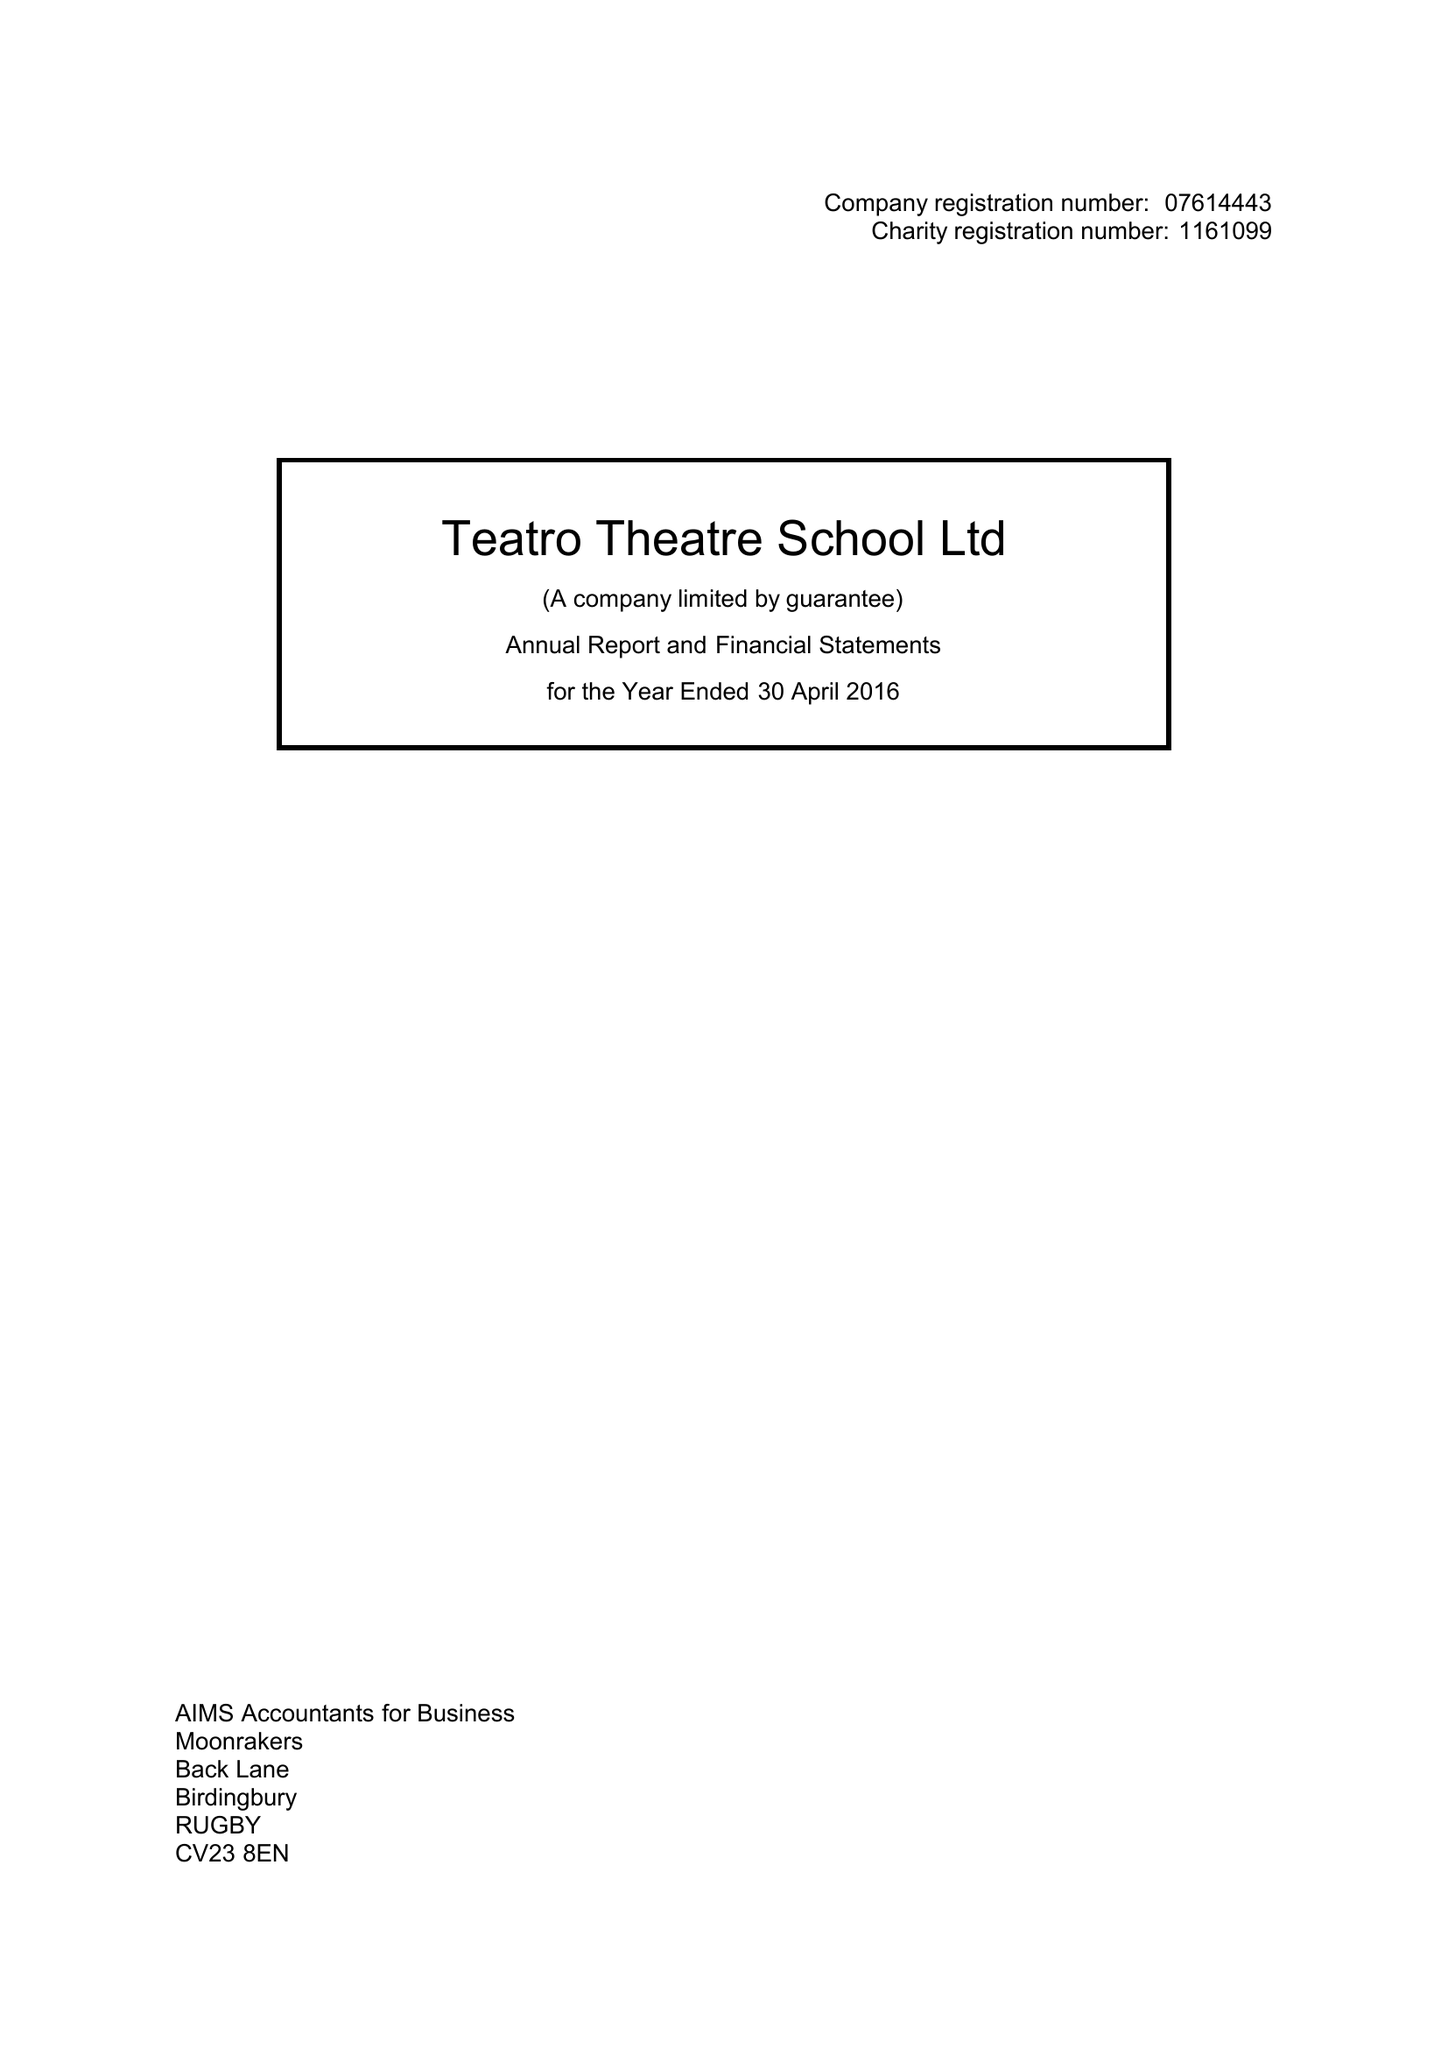What is the value for the report_date?
Answer the question using a single word or phrase. 2016-04-30 